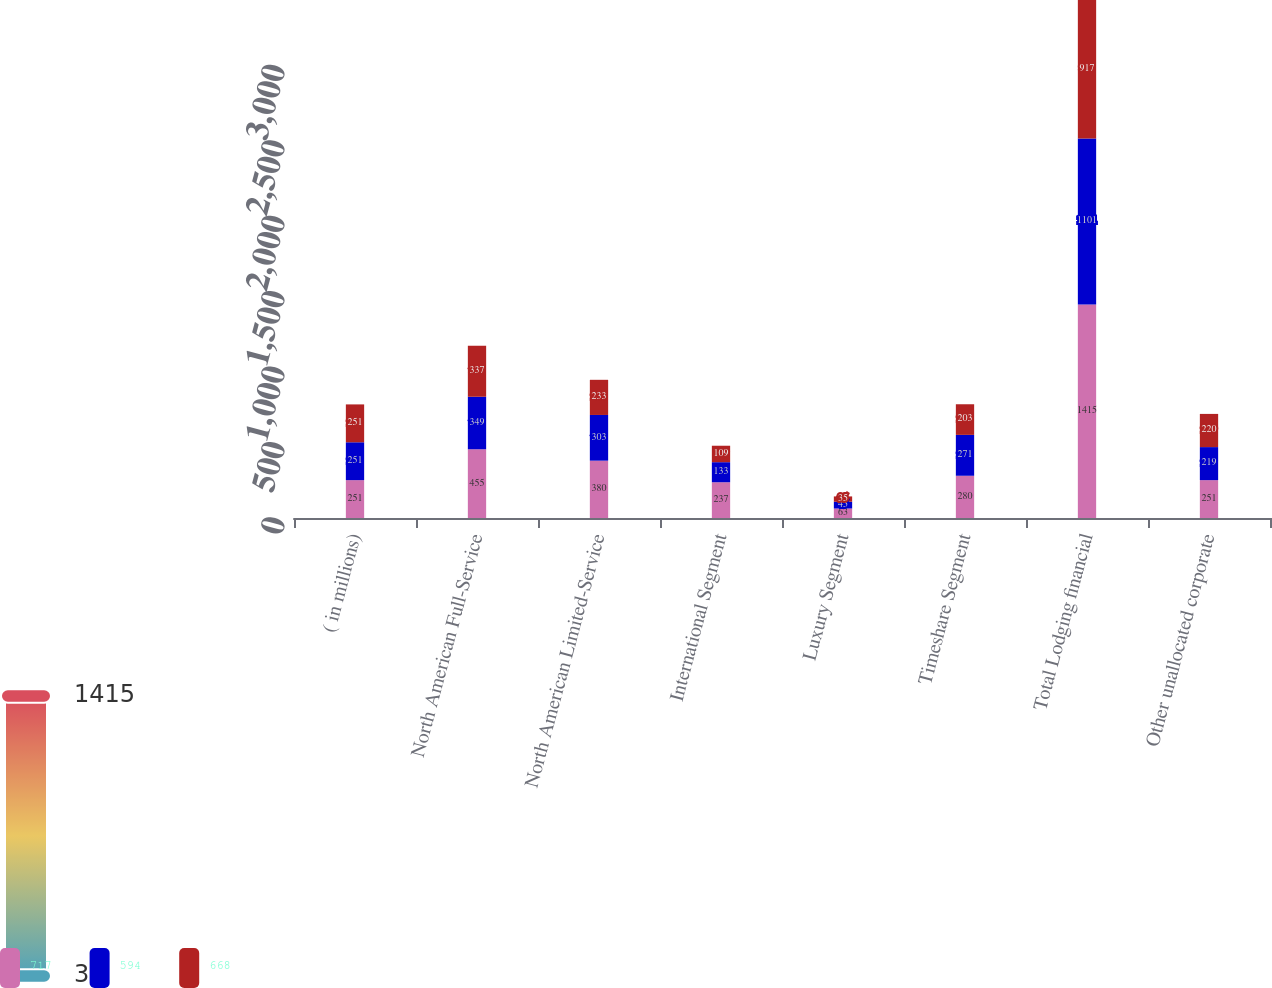<chart> <loc_0><loc_0><loc_500><loc_500><stacked_bar_chart><ecel><fcel>( in millions)<fcel>North American Full-Service<fcel>North American Limited-Service<fcel>International Segment<fcel>Luxury Segment<fcel>Timeshare Segment<fcel>Total Lodging financial<fcel>Other unallocated corporate<nl><fcel>717<fcel>251<fcel>455<fcel>380<fcel>237<fcel>63<fcel>280<fcel>1415<fcel>251<nl><fcel>594<fcel>251<fcel>349<fcel>303<fcel>133<fcel>45<fcel>271<fcel>1101<fcel>219<nl><fcel>668<fcel>251<fcel>337<fcel>233<fcel>109<fcel>35<fcel>203<fcel>917<fcel>220<nl></chart> 